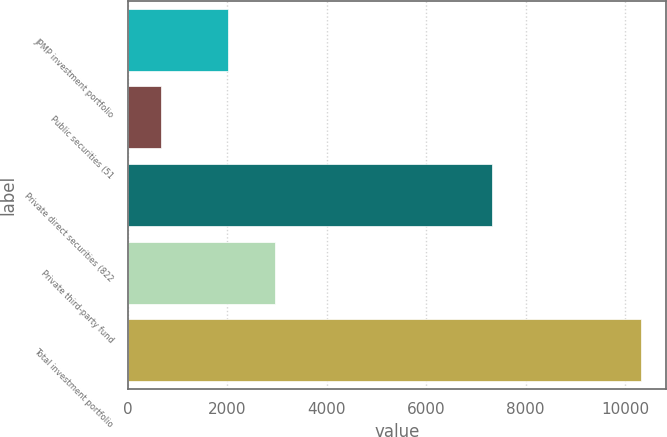Convert chart to OTSL. <chart><loc_0><loc_0><loc_500><loc_500><bar_chart><fcel>JPMP investment portfolio<fcel>Public securities (51<fcel>Private direct securities (822<fcel>Private third-party fund<fcel>Total investment portfolio<nl><fcel>2002<fcel>663<fcel>7316<fcel>2966.9<fcel>10312<nl></chart> 